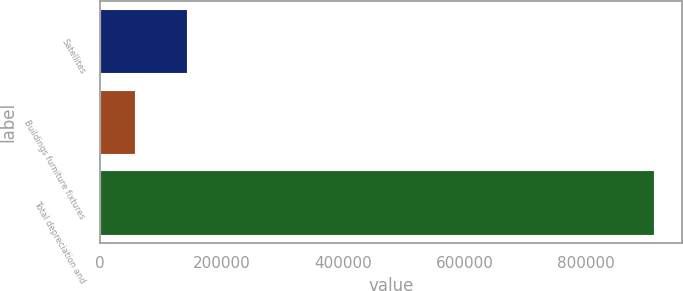Convert chart. <chart><loc_0><loc_0><loc_500><loc_500><bar_chart><fcel>Satellites<fcel>Buildings furniture fixtures<fcel>Total depreciation and<nl><fcel>143373<fcel>57947<fcel>912203<nl></chart> 